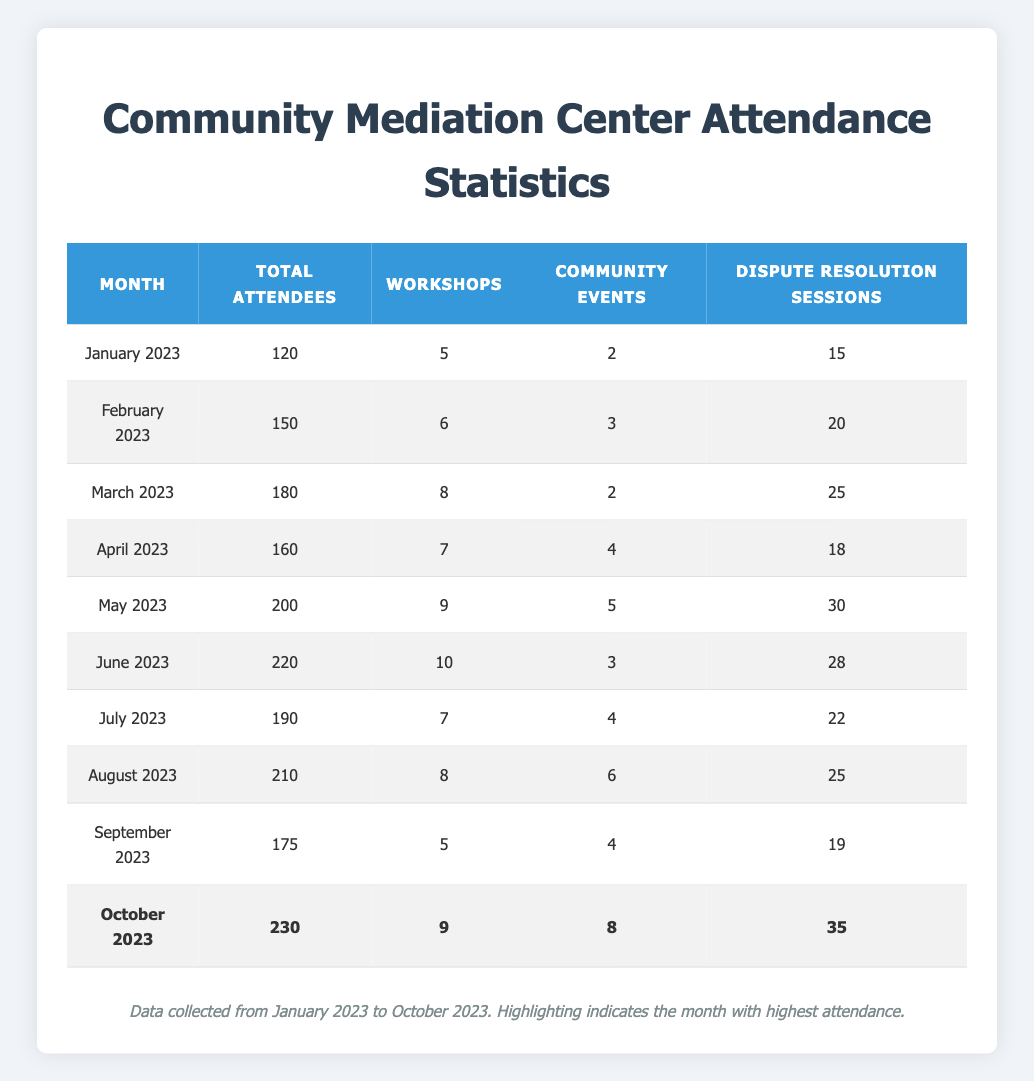What was the total attendance in October 2023? The table shows that the total attendance for October 2023 is listed in the corresponding row as 230.
Answer: 230 How many workshops were held in June 2023? Referring to the June 2023 row in the table, it indicates that 10 workshops were held during that month.
Answer: 10 What is the total number of attendees from January to April 2023? The total number of attendees for each month from January to April are 120, 150, 180, and 160 respectively. Adding these gives: 120 + 150 + 180 + 160 = 610.
Answer: 610 Which month had the highest number of dispute resolution sessions? The table highlights that October 2023 had the highest number of dispute resolution sessions at 35.
Answer: 35 Was there an increase in total attendees from March to April 2023? The total attendees for March 2023 were 180 and for April 2023 were 160. Since 180 is greater than 160, it indicates a decrease, thus the answer is NO.
Answer: No What was the average number of community events held each month from January to September 2023? The total community events were 2, 3, 2, 4, 5, 3, 4, and 6 over the eight months. Summing gives 2 + 3 + 2 + 4 + 5 + 3 + 4 + 6 = 29. Dividing by 8, we get 29/8 = 3.625.
Answer: 3.625 How many more attendees were there in October 2023 compared to the total attendees in May 2023? The total for October 2023 is 230, and for May 2023, it's 200. The difference is: 230 - 200 = 30.
Answer: 30 In which month was there a total attendance of 190? The month with a total attendance of 190 is July 2023, as displayed in that row of the table.
Answer: July 2023 What is the total number of workshops conducted from May to August 2023? Looking at the number of workshops held: May (9), June (10), July (7), and August (8). Summing these gives: 9 + 10 + 7 + 8 = 34.
Answer: 34 Did the number of community events in September 2023 exceed the number of workshops in that same month? In September 2023, there were 4 community events and 5 workshops. Since 4 does not exceed 5, the answer is NO.
Answer: No 